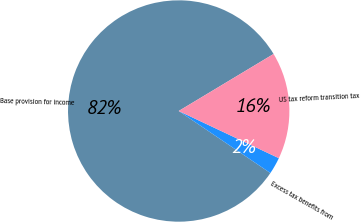Convert chart to OTSL. <chart><loc_0><loc_0><loc_500><loc_500><pie_chart><fcel>Base provision for income<fcel>Excess tax benefits from<fcel>US tax reform transition tax<nl><fcel>81.92%<fcel>2.46%<fcel>15.62%<nl></chart> 